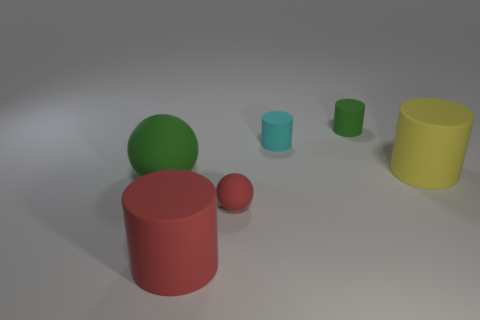Subtract all yellow cylinders. How many cylinders are left? 3 Add 2 matte cylinders. How many objects exist? 8 Subtract 1 cylinders. How many cylinders are left? 3 Subtract all yellow cylinders. How many cylinders are left? 3 Subtract all blue cylinders. Subtract all gray blocks. How many cylinders are left? 4 Subtract 1 yellow cylinders. How many objects are left? 5 Subtract all cylinders. How many objects are left? 2 Subtract all large gray cubes. Subtract all green things. How many objects are left? 4 Add 1 cyan cylinders. How many cyan cylinders are left? 2 Add 2 large rubber objects. How many large rubber objects exist? 5 